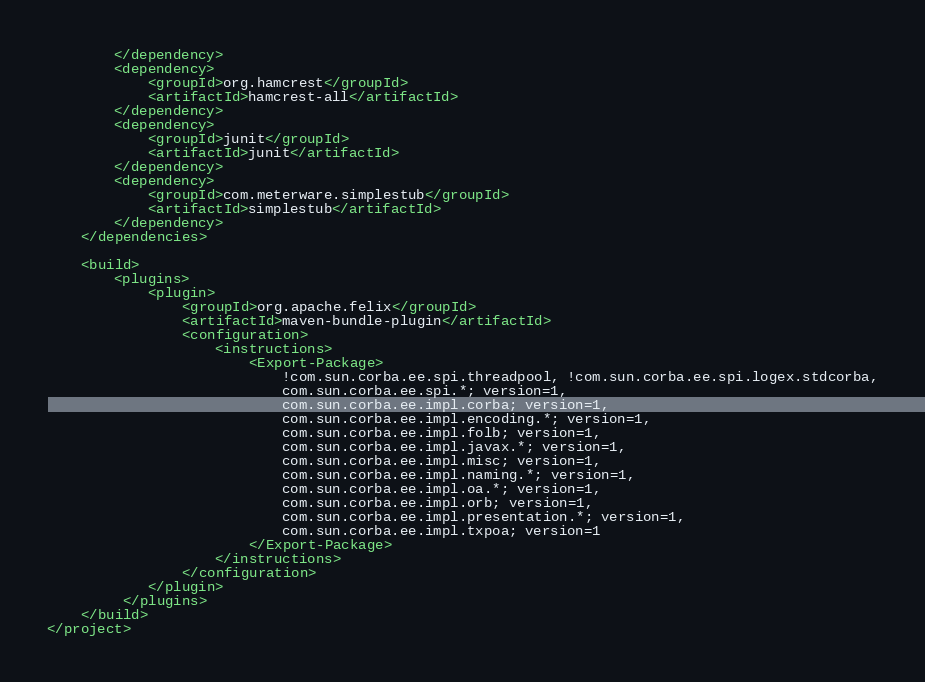Convert code to text. <code><loc_0><loc_0><loc_500><loc_500><_XML_>        </dependency>
        <dependency>
            <groupId>org.hamcrest</groupId>
            <artifactId>hamcrest-all</artifactId>
        </dependency>
        <dependency>
            <groupId>junit</groupId>
            <artifactId>junit</artifactId>
        </dependency>
        <dependency>
            <groupId>com.meterware.simplestub</groupId>
            <artifactId>simplestub</artifactId>
        </dependency>
    </dependencies>

    <build>
        <plugins>
            <plugin>
                <groupId>org.apache.felix</groupId>
                <artifactId>maven-bundle-plugin</artifactId>
                <configuration>
                    <instructions>
                        <Export-Package>
                            !com.sun.corba.ee.spi.threadpool, !com.sun.corba.ee.spi.logex.stdcorba,
                            com.sun.corba.ee.spi.*; version=1,
                            com.sun.corba.ee.impl.corba; version=1,
                            com.sun.corba.ee.impl.encoding.*; version=1,
                            com.sun.corba.ee.impl.folb; version=1,
                            com.sun.corba.ee.impl.javax.*; version=1,
                            com.sun.corba.ee.impl.misc; version=1,
                            com.sun.corba.ee.impl.naming.*; version=1,
                            com.sun.corba.ee.impl.oa.*; version=1,
                            com.sun.corba.ee.impl.orb; version=1,
                            com.sun.corba.ee.impl.presentation.*; version=1,
                            com.sun.corba.ee.impl.txpoa; version=1
                        </Export-Package>
                    </instructions>
                </configuration>
            </plugin>
         </plugins>
    </build>
</project>
</code> 